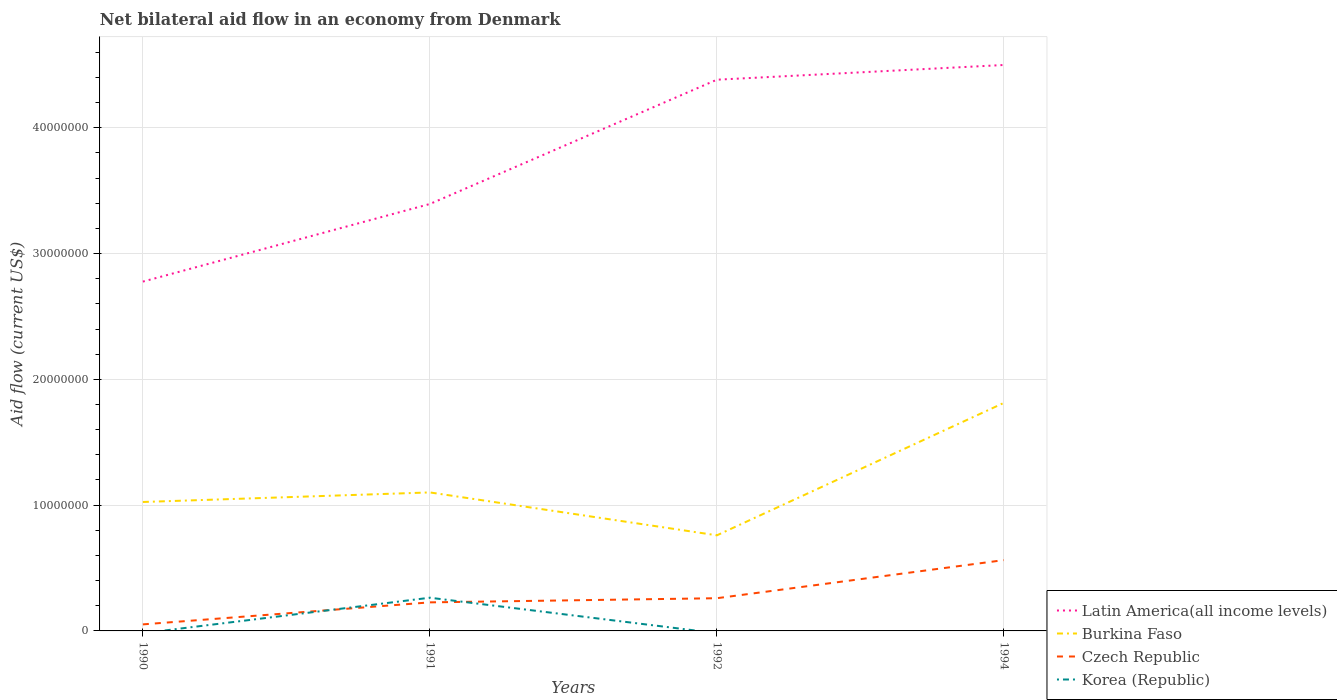Across all years, what is the maximum net bilateral aid flow in Latin America(all income levels)?
Give a very brief answer. 2.78e+07. What is the total net bilateral aid flow in Czech Republic in the graph?
Offer a terse response. -3.36e+06. What is the difference between the highest and the second highest net bilateral aid flow in Burkina Faso?
Make the answer very short. 1.05e+07. What is the difference between the highest and the lowest net bilateral aid flow in Burkina Faso?
Offer a terse response. 1. Is the net bilateral aid flow in Burkina Faso strictly greater than the net bilateral aid flow in Korea (Republic) over the years?
Make the answer very short. No. What is the difference between two consecutive major ticks on the Y-axis?
Your response must be concise. 1.00e+07. Are the values on the major ticks of Y-axis written in scientific E-notation?
Your answer should be very brief. No. Does the graph contain any zero values?
Provide a short and direct response. Yes. Does the graph contain grids?
Your answer should be very brief. Yes. What is the title of the graph?
Make the answer very short. Net bilateral aid flow in an economy from Denmark. What is the label or title of the Y-axis?
Offer a very short reply. Aid flow (current US$). What is the Aid flow (current US$) of Latin America(all income levels) in 1990?
Keep it short and to the point. 2.78e+07. What is the Aid flow (current US$) of Burkina Faso in 1990?
Offer a terse response. 1.02e+07. What is the Aid flow (current US$) of Czech Republic in 1990?
Your response must be concise. 5.20e+05. What is the Aid flow (current US$) of Latin America(all income levels) in 1991?
Your answer should be compact. 3.39e+07. What is the Aid flow (current US$) in Burkina Faso in 1991?
Provide a succinct answer. 1.10e+07. What is the Aid flow (current US$) of Czech Republic in 1991?
Ensure brevity in your answer.  2.27e+06. What is the Aid flow (current US$) of Korea (Republic) in 1991?
Your answer should be very brief. 2.64e+06. What is the Aid flow (current US$) in Latin America(all income levels) in 1992?
Your response must be concise. 4.38e+07. What is the Aid flow (current US$) of Burkina Faso in 1992?
Offer a very short reply. 7.60e+06. What is the Aid flow (current US$) in Czech Republic in 1992?
Give a very brief answer. 2.60e+06. What is the Aid flow (current US$) of Korea (Republic) in 1992?
Provide a short and direct response. 0. What is the Aid flow (current US$) of Latin America(all income levels) in 1994?
Provide a short and direct response. 4.50e+07. What is the Aid flow (current US$) in Burkina Faso in 1994?
Your response must be concise. 1.81e+07. What is the Aid flow (current US$) in Czech Republic in 1994?
Provide a short and direct response. 5.63e+06. Across all years, what is the maximum Aid flow (current US$) of Latin America(all income levels)?
Make the answer very short. 4.50e+07. Across all years, what is the maximum Aid flow (current US$) in Burkina Faso?
Offer a very short reply. 1.81e+07. Across all years, what is the maximum Aid flow (current US$) in Czech Republic?
Offer a very short reply. 5.63e+06. Across all years, what is the maximum Aid flow (current US$) of Korea (Republic)?
Your response must be concise. 2.64e+06. Across all years, what is the minimum Aid flow (current US$) in Latin America(all income levels)?
Provide a succinct answer. 2.78e+07. Across all years, what is the minimum Aid flow (current US$) in Burkina Faso?
Provide a succinct answer. 7.60e+06. Across all years, what is the minimum Aid flow (current US$) in Czech Republic?
Ensure brevity in your answer.  5.20e+05. What is the total Aid flow (current US$) of Latin America(all income levels) in the graph?
Offer a very short reply. 1.51e+08. What is the total Aid flow (current US$) in Burkina Faso in the graph?
Offer a terse response. 4.70e+07. What is the total Aid flow (current US$) of Czech Republic in the graph?
Make the answer very short. 1.10e+07. What is the total Aid flow (current US$) in Korea (Republic) in the graph?
Your answer should be compact. 2.64e+06. What is the difference between the Aid flow (current US$) of Latin America(all income levels) in 1990 and that in 1991?
Offer a very short reply. -6.17e+06. What is the difference between the Aid flow (current US$) of Burkina Faso in 1990 and that in 1991?
Your answer should be very brief. -7.60e+05. What is the difference between the Aid flow (current US$) in Czech Republic in 1990 and that in 1991?
Ensure brevity in your answer.  -1.75e+06. What is the difference between the Aid flow (current US$) in Latin America(all income levels) in 1990 and that in 1992?
Give a very brief answer. -1.60e+07. What is the difference between the Aid flow (current US$) in Burkina Faso in 1990 and that in 1992?
Provide a short and direct response. 2.65e+06. What is the difference between the Aid flow (current US$) in Czech Republic in 1990 and that in 1992?
Offer a terse response. -2.08e+06. What is the difference between the Aid flow (current US$) of Latin America(all income levels) in 1990 and that in 1994?
Ensure brevity in your answer.  -1.72e+07. What is the difference between the Aid flow (current US$) of Burkina Faso in 1990 and that in 1994?
Make the answer very short. -7.88e+06. What is the difference between the Aid flow (current US$) in Czech Republic in 1990 and that in 1994?
Keep it short and to the point. -5.11e+06. What is the difference between the Aid flow (current US$) of Latin America(all income levels) in 1991 and that in 1992?
Give a very brief answer. -9.88e+06. What is the difference between the Aid flow (current US$) in Burkina Faso in 1991 and that in 1992?
Provide a succinct answer. 3.41e+06. What is the difference between the Aid flow (current US$) in Czech Republic in 1991 and that in 1992?
Keep it short and to the point. -3.30e+05. What is the difference between the Aid flow (current US$) in Latin America(all income levels) in 1991 and that in 1994?
Provide a short and direct response. -1.10e+07. What is the difference between the Aid flow (current US$) of Burkina Faso in 1991 and that in 1994?
Your answer should be very brief. -7.12e+06. What is the difference between the Aid flow (current US$) in Czech Republic in 1991 and that in 1994?
Offer a very short reply. -3.36e+06. What is the difference between the Aid flow (current US$) of Latin America(all income levels) in 1992 and that in 1994?
Offer a terse response. -1.17e+06. What is the difference between the Aid flow (current US$) of Burkina Faso in 1992 and that in 1994?
Offer a very short reply. -1.05e+07. What is the difference between the Aid flow (current US$) of Czech Republic in 1992 and that in 1994?
Offer a terse response. -3.03e+06. What is the difference between the Aid flow (current US$) in Latin America(all income levels) in 1990 and the Aid flow (current US$) in Burkina Faso in 1991?
Provide a short and direct response. 1.68e+07. What is the difference between the Aid flow (current US$) in Latin America(all income levels) in 1990 and the Aid flow (current US$) in Czech Republic in 1991?
Your answer should be compact. 2.55e+07. What is the difference between the Aid flow (current US$) of Latin America(all income levels) in 1990 and the Aid flow (current US$) of Korea (Republic) in 1991?
Provide a short and direct response. 2.51e+07. What is the difference between the Aid flow (current US$) in Burkina Faso in 1990 and the Aid flow (current US$) in Czech Republic in 1991?
Ensure brevity in your answer.  7.98e+06. What is the difference between the Aid flow (current US$) in Burkina Faso in 1990 and the Aid flow (current US$) in Korea (Republic) in 1991?
Provide a short and direct response. 7.61e+06. What is the difference between the Aid flow (current US$) of Czech Republic in 1990 and the Aid flow (current US$) of Korea (Republic) in 1991?
Give a very brief answer. -2.12e+06. What is the difference between the Aid flow (current US$) of Latin America(all income levels) in 1990 and the Aid flow (current US$) of Burkina Faso in 1992?
Your response must be concise. 2.02e+07. What is the difference between the Aid flow (current US$) in Latin America(all income levels) in 1990 and the Aid flow (current US$) in Czech Republic in 1992?
Offer a very short reply. 2.52e+07. What is the difference between the Aid flow (current US$) of Burkina Faso in 1990 and the Aid flow (current US$) of Czech Republic in 1992?
Give a very brief answer. 7.65e+06. What is the difference between the Aid flow (current US$) of Latin America(all income levels) in 1990 and the Aid flow (current US$) of Burkina Faso in 1994?
Your response must be concise. 9.64e+06. What is the difference between the Aid flow (current US$) of Latin America(all income levels) in 1990 and the Aid flow (current US$) of Czech Republic in 1994?
Offer a terse response. 2.21e+07. What is the difference between the Aid flow (current US$) in Burkina Faso in 1990 and the Aid flow (current US$) in Czech Republic in 1994?
Your answer should be very brief. 4.62e+06. What is the difference between the Aid flow (current US$) in Latin America(all income levels) in 1991 and the Aid flow (current US$) in Burkina Faso in 1992?
Ensure brevity in your answer.  2.63e+07. What is the difference between the Aid flow (current US$) in Latin America(all income levels) in 1991 and the Aid flow (current US$) in Czech Republic in 1992?
Provide a short and direct response. 3.13e+07. What is the difference between the Aid flow (current US$) of Burkina Faso in 1991 and the Aid flow (current US$) of Czech Republic in 1992?
Your answer should be very brief. 8.41e+06. What is the difference between the Aid flow (current US$) of Latin America(all income levels) in 1991 and the Aid flow (current US$) of Burkina Faso in 1994?
Provide a short and direct response. 1.58e+07. What is the difference between the Aid flow (current US$) of Latin America(all income levels) in 1991 and the Aid flow (current US$) of Czech Republic in 1994?
Give a very brief answer. 2.83e+07. What is the difference between the Aid flow (current US$) of Burkina Faso in 1991 and the Aid flow (current US$) of Czech Republic in 1994?
Give a very brief answer. 5.38e+06. What is the difference between the Aid flow (current US$) in Latin America(all income levels) in 1992 and the Aid flow (current US$) in Burkina Faso in 1994?
Give a very brief answer. 2.57e+07. What is the difference between the Aid flow (current US$) of Latin America(all income levels) in 1992 and the Aid flow (current US$) of Czech Republic in 1994?
Offer a very short reply. 3.82e+07. What is the difference between the Aid flow (current US$) of Burkina Faso in 1992 and the Aid flow (current US$) of Czech Republic in 1994?
Your answer should be very brief. 1.97e+06. What is the average Aid flow (current US$) of Latin America(all income levels) per year?
Your response must be concise. 3.76e+07. What is the average Aid flow (current US$) in Burkina Faso per year?
Provide a short and direct response. 1.17e+07. What is the average Aid flow (current US$) in Czech Republic per year?
Offer a very short reply. 2.76e+06. In the year 1990, what is the difference between the Aid flow (current US$) of Latin America(all income levels) and Aid flow (current US$) of Burkina Faso?
Your response must be concise. 1.75e+07. In the year 1990, what is the difference between the Aid flow (current US$) of Latin America(all income levels) and Aid flow (current US$) of Czech Republic?
Offer a very short reply. 2.72e+07. In the year 1990, what is the difference between the Aid flow (current US$) in Burkina Faso and Aid flow (current US$) in Czech Republic?
Your answer should be compact. 9.73e+06. In the year 1991, what is the difference between the Aid flow (current US$) of Latin America(all income levels) and Aid flow (current US$) of Burkina Faso?
Ensure brevity in your answer.  2.29e+07. In the year 1991, what is the difference between the Aid flow (current US$) of Latin America(all income levels) and Aid flow (current US$) of Czech Republic?
Ensure brevity in your answer.  3.17e+07. In the year 1991, what is the difference between the Aid flow (current US$) in Latin America(all income levels) and Aid flow (current US$) in Korea (Republic)?
Provide a succinct answer. 3.13e+07. In the year 1991, what is the difference between the Aid flow (current US$) in Burkina Faso and Aid flow (current US$) in Czech Republic?
Give a very brief answer. 8.74e+06. In the year 1991, what is the difference between the Aid flow (current US$) of Burkina Faso and Aid flow (current US$) of Korea (Republic)?
Make the answer very short. 8.37e+06. In the year 1991, what is the difference between the Aid flow (current US$) in Czech Republic and Aid flow (current US$) in Korea (Republic)?
Make the answer very short. -3.70e+05. In the year 1992, what is the difference between the Aid flow (current US$) in Latin America(all income levels) and Aid flow (current US$) in Burkina Faso?
Provide a short and direct response. 3.62e+07. In the year 1992, what is the difference between the Aid flow (current US$) of Latin America(all income levels) and Aid flow (current US$) of Czech Republic?
Make the answer very short. 4.12e+07. In the year 1994, what is the difference between the Aid flow (current US$) of Latin America(all income levels) and Aid flow (current US$) of Burkina Faso?
Provide a succinct answer. 2.69e+07. In the year 1994, what is the difference between the Aid flow (current US$) of Latin America(all income levels) and Aid flow (current US$) of Czech Republic?
Your response must be concise. 3.94e+07. In the year 1994, what is the difference between the Aid flow (current US$) of Burkina Faso and Aid flow (current US$) of Czech Republic?
Ensure brevity in your answer.  1.25e+07. What is the ratio of the Aid flow (current US$) of Latin America(all income levels) in 1990 to that in 1991?
Offer a terse response. 0.82. What is the ratio of the Aid flow (current US$) in Burkina Faso in 1990 to that in 1991?
Provide a short and direct response. 0.93. What is the ratio of the Aid flow (current US$) of Czech Republic in 1990 to that in 1991?
Your answer should be compact. 0.23. What is the ratio of the Aid flow (current US$) of Latin America(all income levels) in 1990 to that in 1992?
Keep it short and to the point. 0.63. What is the ratio of the Aid flow (current US$) in Burkina Faso in 1990 to that in 1992?
Your response must be concise. 1.35. What is the ratio of the Aid flow (current US$) in Latin America(all income levels) in 1990 to that in 1994?
Provide a short and direct response. 0.62. What is the ratio of the Aid flow (current US$) in Burkina Faso in 1990 to that in 1994?
Provide a succinct answer. 0.57. What is the ratio of the Aid flow (current US$) of Czech Republic in 1990 to that in 1994?
Make the answer very short. 0.09. What is the ratio of the Aid flow (current US$) of Latin America(all income levels) in 1991 to that in 1992?
Your answer should be compact. 0.77. What is the ratio of the Aid flow (current US$) of Burkina Faso in 1991 to that in 1992?
Give a very brief answer. 1.45. What is the ratio of the Aid flow (current US$) in Czech Republic in 1991 to that in 1992?
Offer a very short reply. 0.87. What is the ratio of the Aid flow (current US$) in Latin America(all income levels) in 1991 to that in 1994?
Make the answer very short. 0.75. What is the ratio of the Aid flow (current US$) of Burkina Faso in 1991 to that in 1994?
Offer a very short reply. 0.61. What is the ratio of the Aid flow (current US$) in Czech Republic in 1991 to that in 1994?
Offer a terse response. 0.4. What is the ratio of the Aid flow (current US$) in Burkina Faso in 1992 to that in 1994?
Give a very brief answer. 0.42. What is the ratio of the Aid flow (current US$) of Czech Republic in 1992 to that in 1994?
Provide a succinct answer. 0.46. What is the difference between the highest and the second highest Aid flow (current US$) in Latin America(all income levels)?
Your response must be concise. 1.17e+06. What is the difference between the highest and the second highest Aid flow (current US$) of Burkina Faso?
Ensure brevity in your answer.  7.12e+06. What is the difference between the highest and the second highest Aid flow (current US$) of Czech Republic?
Offer a very short reply. 3.03e+06. What is the difference between the highest and the lowest Aid flow (current US$) in Latin America(all income levels)?
Give a very brief answer. 1.72e+07. What is the difference between the highest and the lowest Aid flow (current US$) in Burkina Faso?
Make the answer very short. 1.05e+07. What is the difference between the highest and the lowest Aid flow (current US$) in Czech Republic?
Make the answer very short. 5.11e+06. What is the difference between the highest and the lowest Aid flow (current US$) in Korea (Republic)?
Your response must be concise. 2.64e+06. 